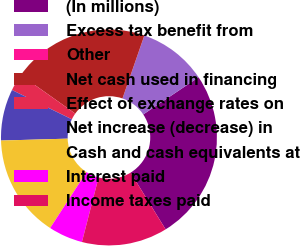Convert chart. <chart><loc_0><loc_0><loc_500><loc_500><pie_chart><fcel>(In millions)<fcel>Excess tax benefit from<fcel>Other<fcel>Net cash used in financing<fcel>Effect of exchange rates on<fcel>Net increase (decrease) in<fcel>Cash and cash equivalents at<fcel>Interest paid<fcel>Income taxes paid<nl><fcel>25.62%<fcel>10.26%<fcel>0.01%<fcel>20.5%<fcel>2.57%<fcel>7.7%<fcel>15.38%<fcel>5.14%<fcel>12.82%<nl></chart> 